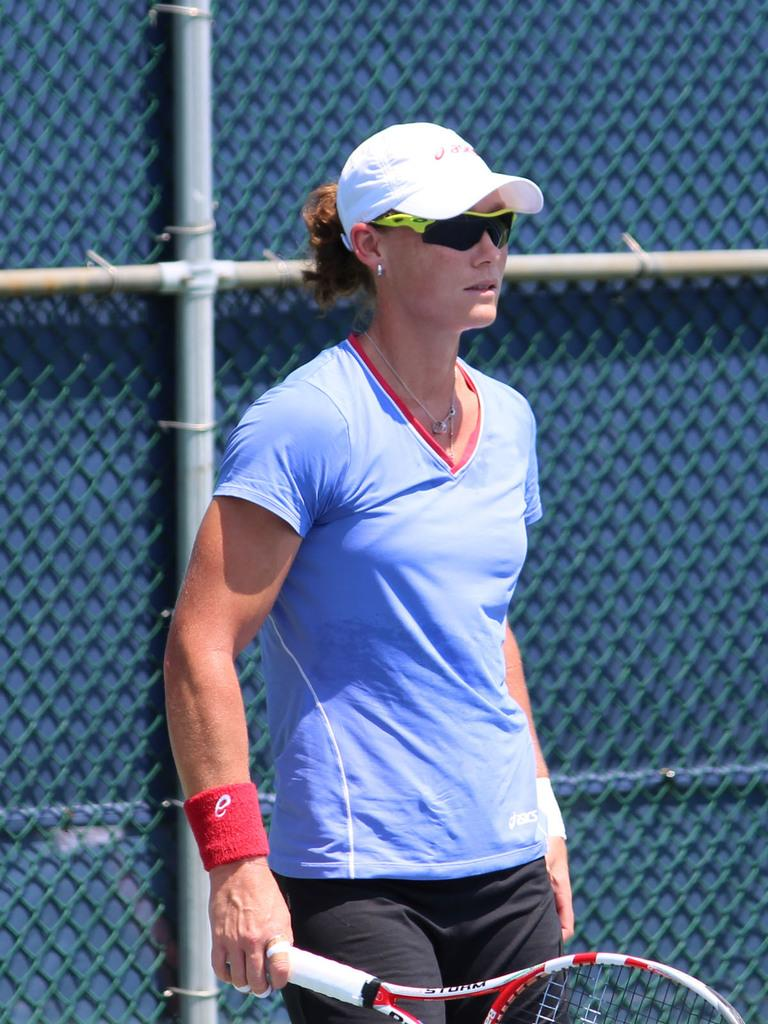Who is the main subject in the image? There is a woman in the image. Where is the woman positioned in the image? The woman is standing in the middle of the image. What is the woman holding in the image? The woman is holding a tennis racket. What can be seen in the background of the image? There is a fencing visible behind the woman. What is the process of tasting the tennis racket in the image? There is no process of tasting the tennis racket in the image, as it is a sports equipment and not a food item. 